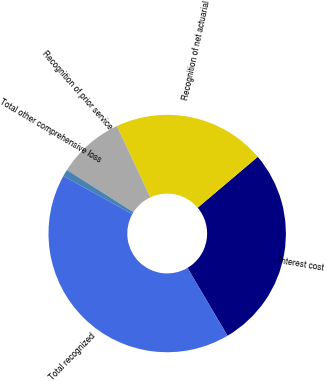<chart> <loc_0><loc_0><loc_500><loc_500><pie_chart><fcel>Interest cost<fcel>Recognition of net actuarial<fcel>Recognition of prior service<fcel>Total other comprehensive loss<fcel>Total recognized<nl><fcel>27.7%<fcel>20.78%<fcel>9.05%<fcel>0.92%<fcel>41.55%<nl></chart> 